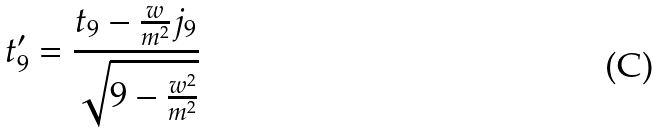Convert formula to latex. <formula><loc_0><loc_0><loc_500><loc_500>t _ { 9 } ^ { \prime } = \frac { t _ { 9 } - \frac { w } { m ^ { 2 } } j _ { 9 } } { \sqrt { 9 - \frac { w ^ { 2 } } { m ^ { 2 } } } }</formula> 